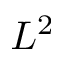<formula> <loc_0><loc_0><loc_500><loc_500>L ^ { 2 }</formula> 